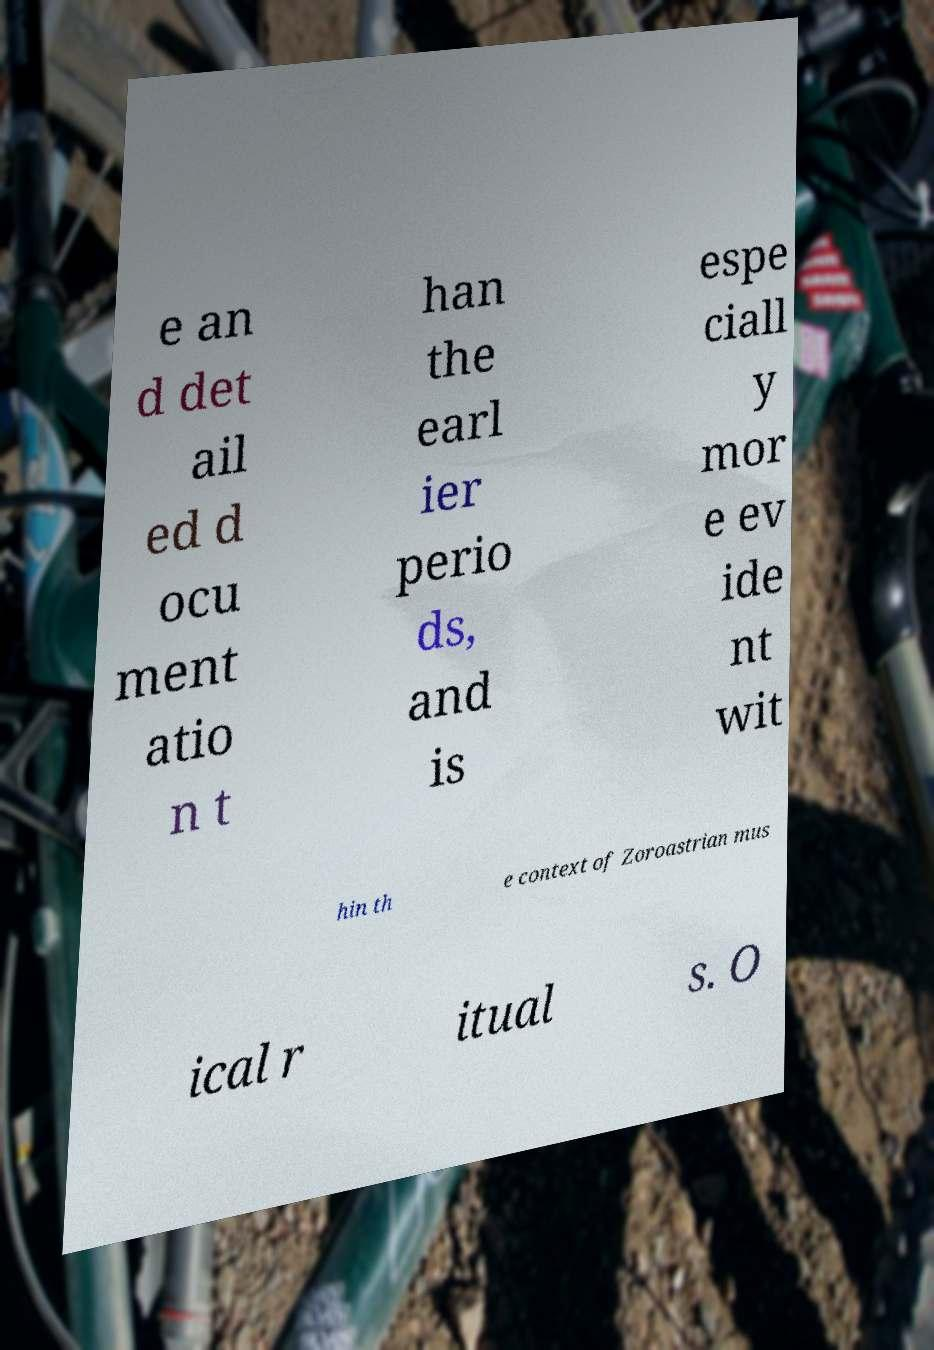There's text embedded in this image that I need extracted. Can you transcribe it verbatim? e an d det ail ed d ocu ment atio n t han the earl ier perio ds, and is espe ciall y mor e ev ide nt wit hin th e context of Zoroastrian mus ical r itual s. O 